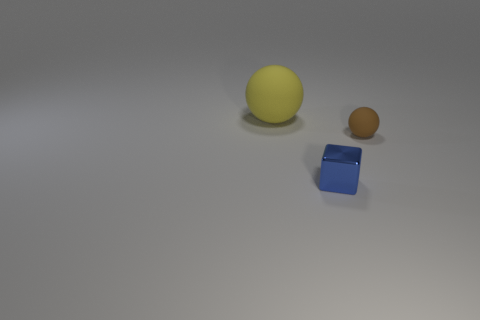Is there anything else that is made of the same material as the blue block?
Your answer should be compact. No. What number of large yellow things are the same shape as the small metal object?
Your response must be concise. 0. Do the ball behind the brown matte ball and the object in front of the brown matte thing have the same size?
Keep it short and to the point. No. What is the shape of the tiny thing that is in front of the tiny brown sphere?
Ensure brevity in your answer.  Cube. There is a small object that is the same shape as the large yellow object; what is its material?
Keep it short and to the point. Rubber. There is a rubber sphere that is on the right side of the blue cube; is its size the same as the big yellow ball?
Your answer should be very brief. No. How many blue metal things are in front of the small shiny thing?
Your response must be concise. 0. Is the number of small cubes to the left of the blue metal thing less than the number of brown rubber objects on the right side of the yellow rubber ball?
Ensure brevity in your answer.  Yes. How many tiny things are there?
Offer a terse response. 2. What is the color of the rubber ball on the left side of the brown thing?
Your answer should be compact. Yellow. 